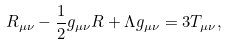Convert formula to latex. <formula><loc_0><loc_0><loc_500><loc_500>R _ { \mu \nu } - \frac { 1 } { 2 } g _ { \mu \nu } R + \Lambda g _ { \mu \nu } = 3 T _ { \mu \nu } ,</formula> 